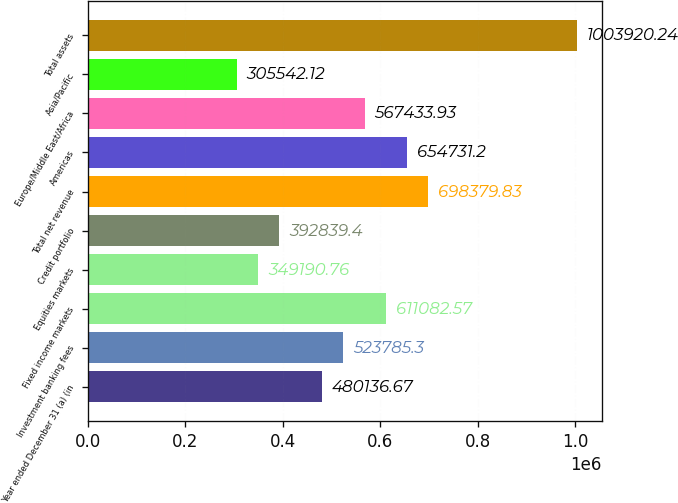Convert chart. <chart><loc_0><loc_0><loc_500><loc_500><bar_chart><fcel>Year ended December 31 (a) (in<fcel>Investment banking fees<fcel>Fixed income markets<fcel>Equities markets<fcel>Credit portfolio<fcel>Total net revenue<fcel>Americas<fcel>Europe/Middle East/Africa<fcel>Asia/Pacific<fcel>Total assets<nl><fcel>480137<fcel>523785<fcel>611083<fcel>349191<fcel>392839<fcel>698380<fcel>654731<fcel>567434<fcel>305542<fcel>1.00392e+06<nl></chart> 